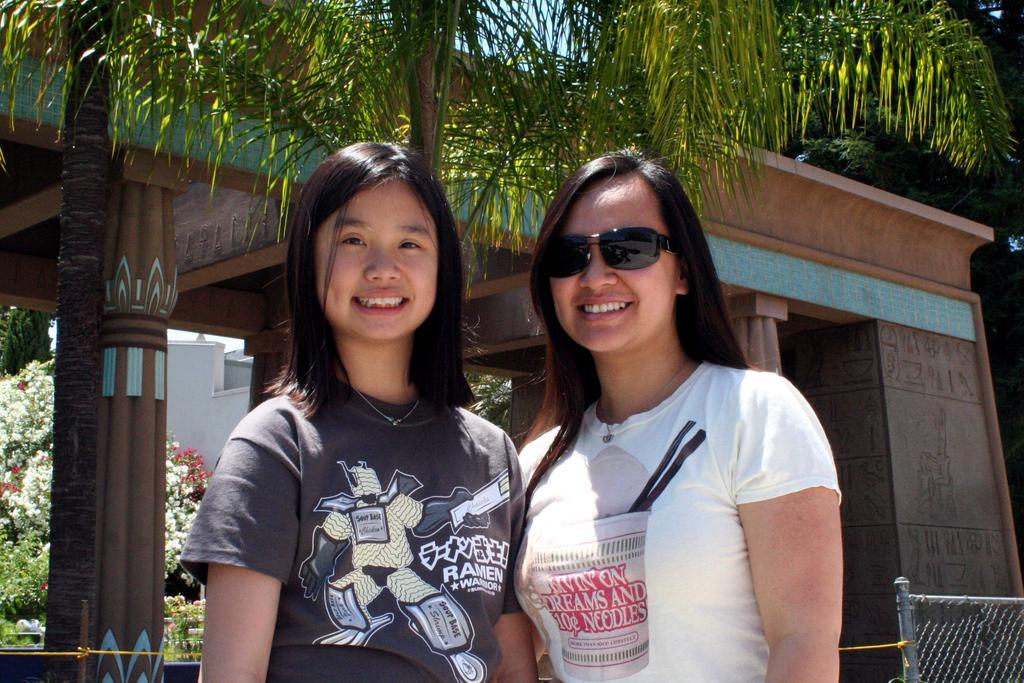Could you give a brief overview of what you see in this image? In this image we can see two persons standing and smiling, among them one person is wearing goggles, behind them, we can see a building, there are some pillars, flowers, trees and plants, also we can see the sky. 